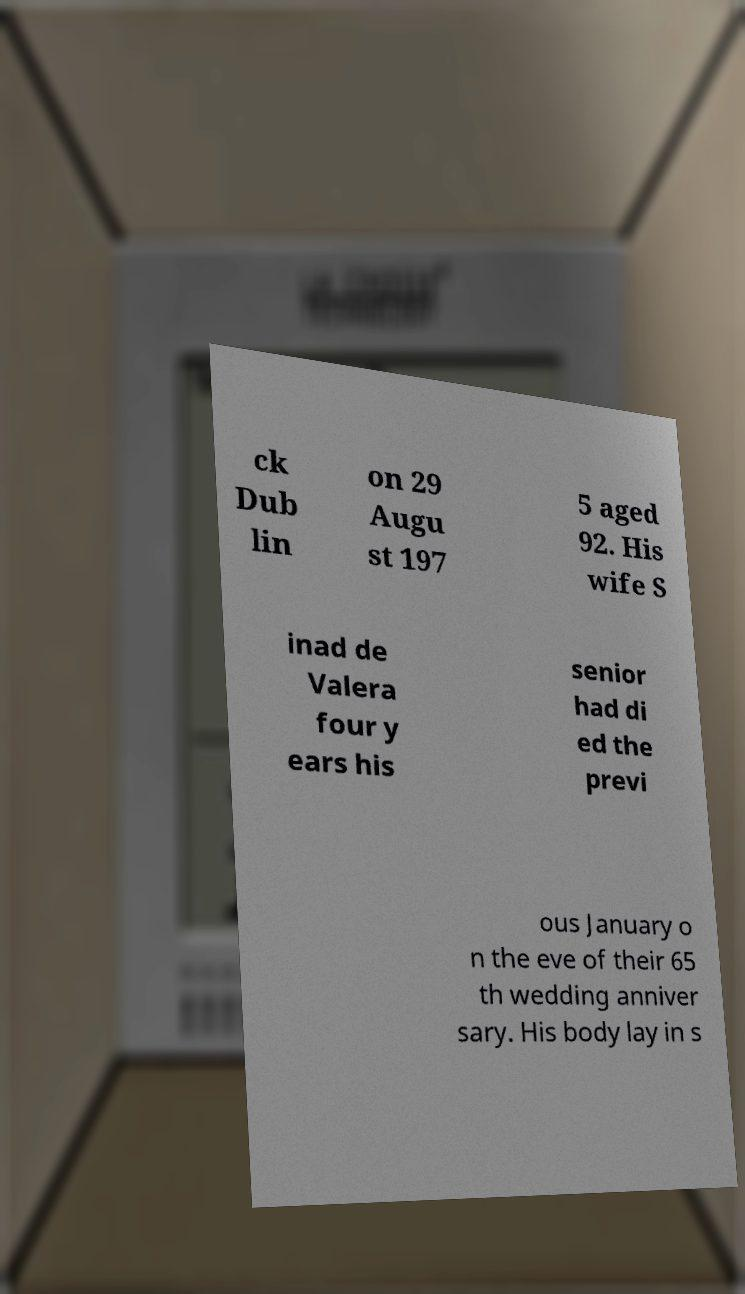For documentation purposes, I need the text within this image transcribed. Could you provide that? ck Dub lin on 29 Augu st 197 5 aged 92. His wife S inad de Valera four y ears his senior had di ed the previ ous January o n the eve of their 65 th wedding anniver sary. His body lay in s 